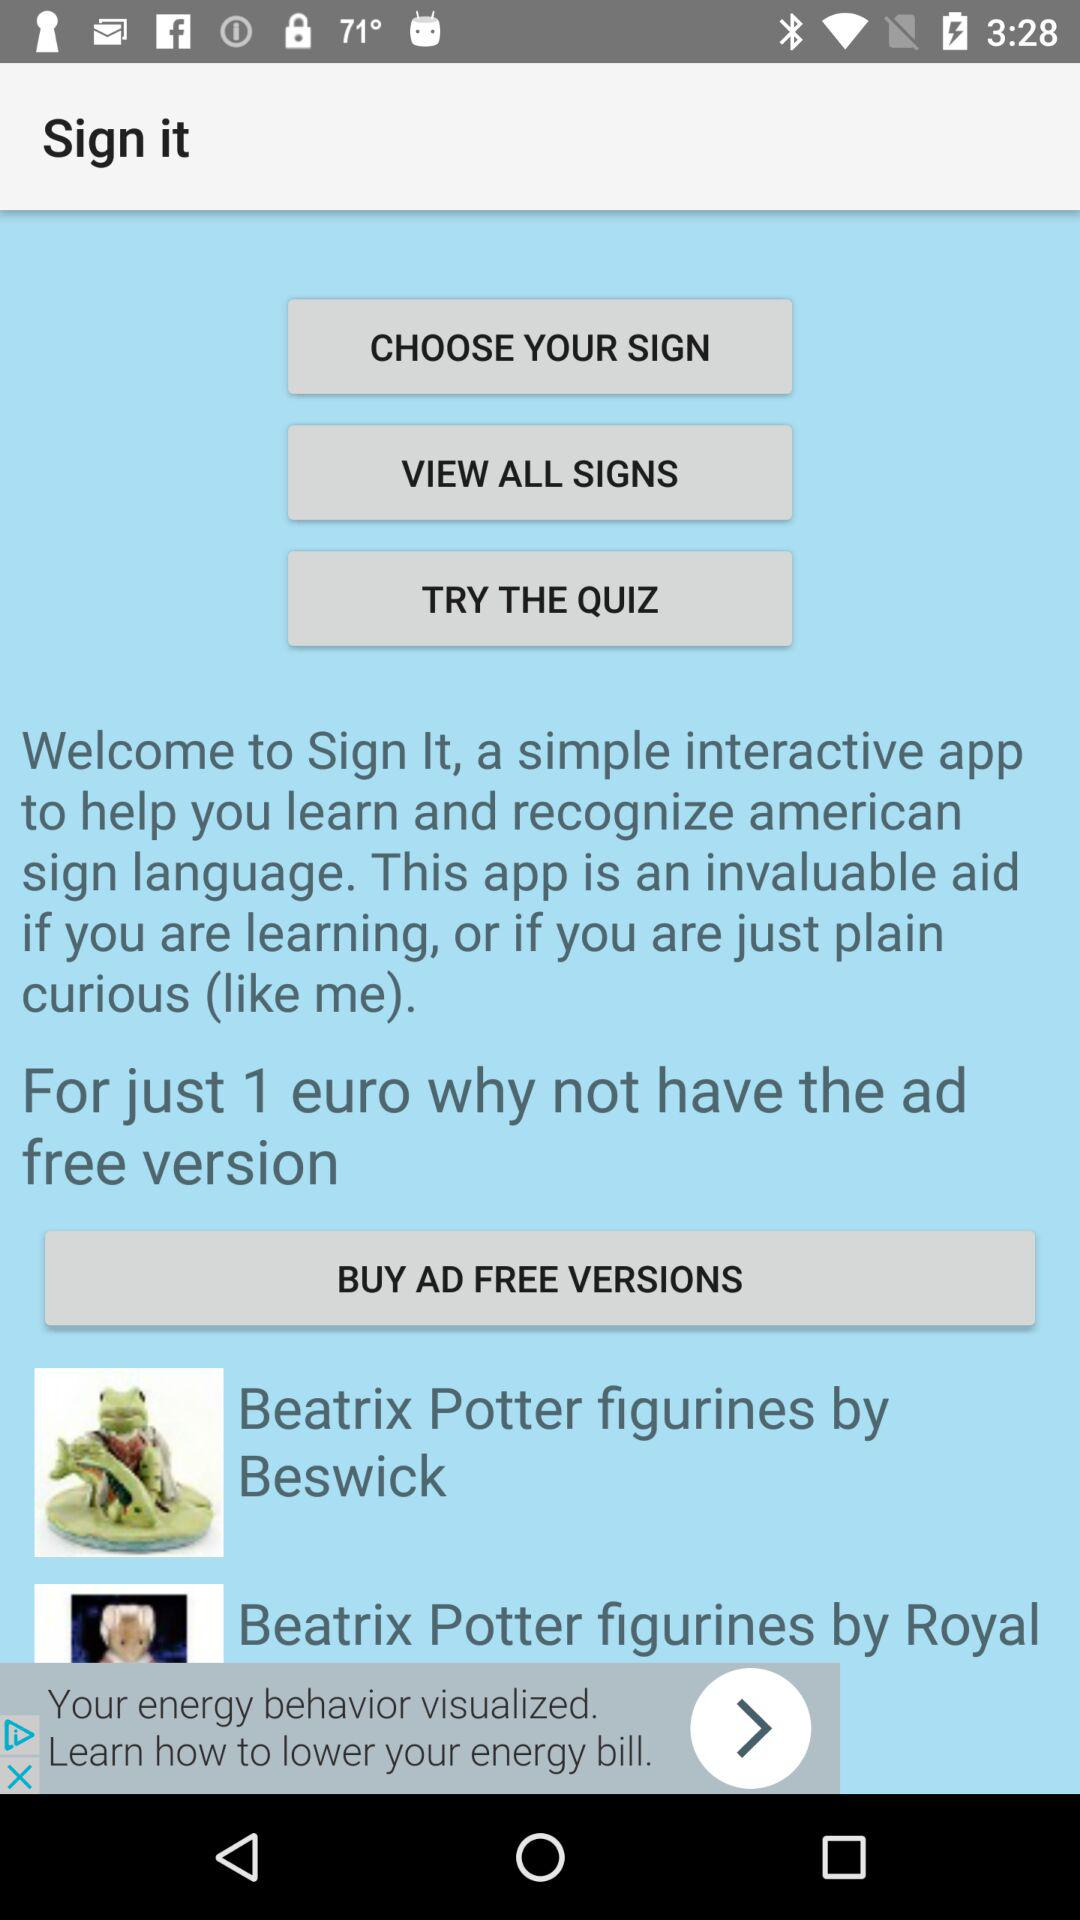For how many euros will we get the ad-free version? You will get the ad-free version for 1 euro. 